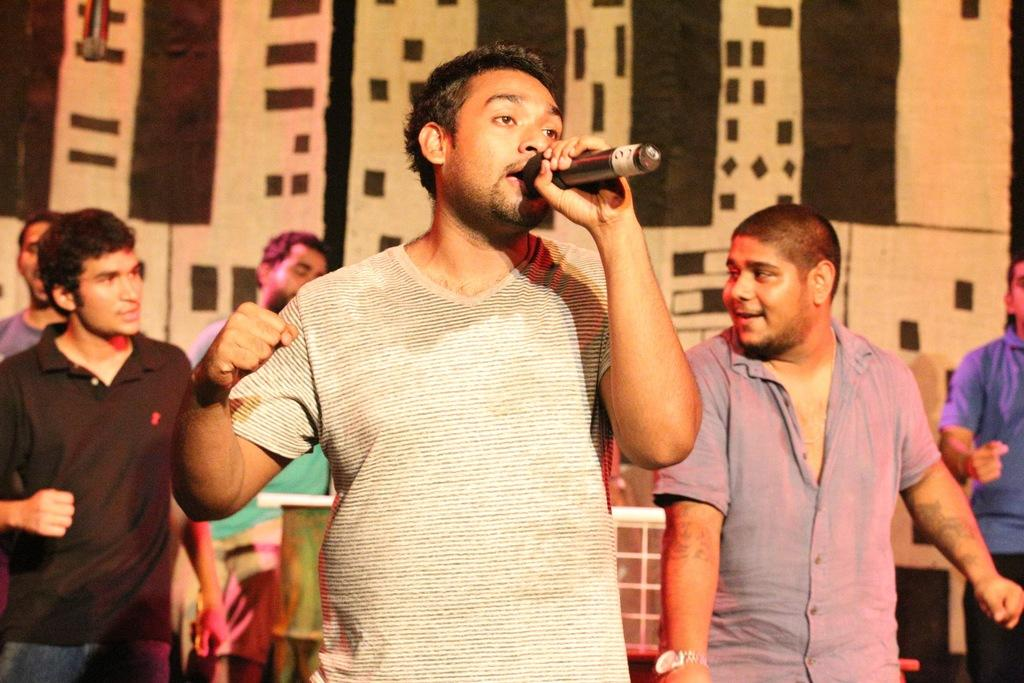What is the main subject of the image? There is a person in the image. What is the person holding in their left hand? The person is holding a microphone in their left hand. Are there any other people visible in the image? Yes, there are other people visible in the image. What type of potato is being used as a prop in the image? There is no potato present in the image. 